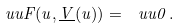<formula> <loc_0><loc_0><loc_500><loc_500>\ u u { F } ( u , \underline { V } ( u ) ) = \ u u { 0 } \, .</formula> 